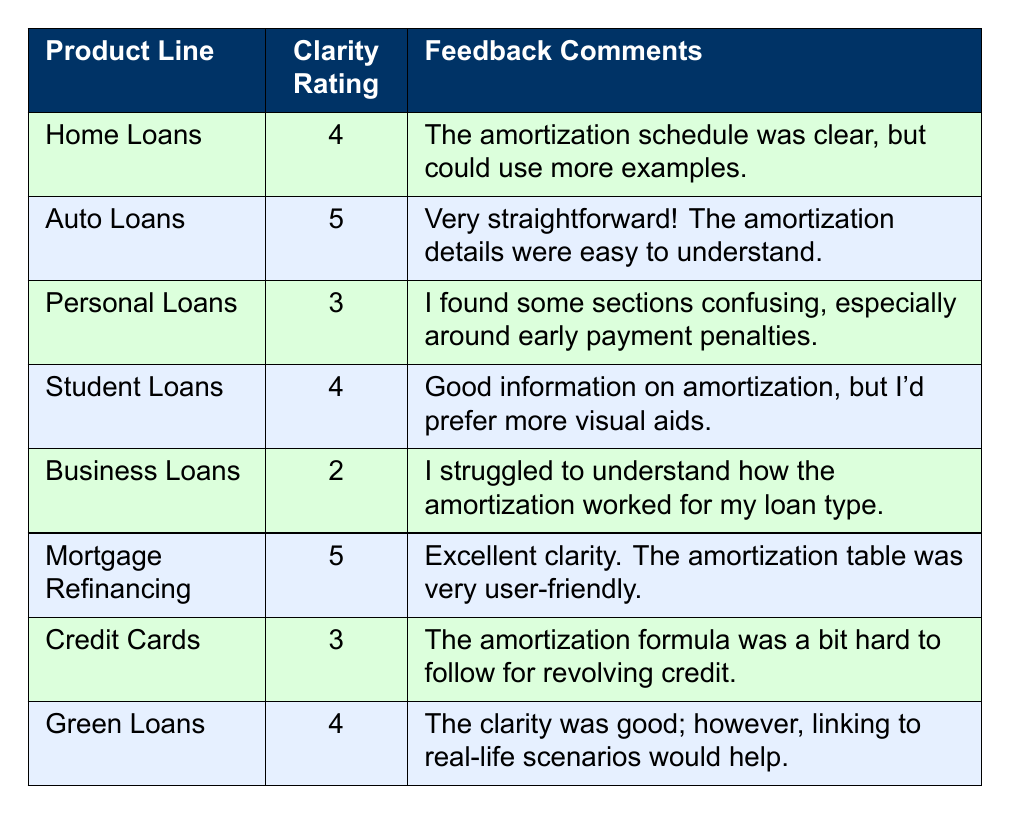What is the clarity rating for Business Loans? The table lists the clarity rating for Business Loans under the "Clarity Rating" column, which shows the value of 2.
Answer: 2 Which product line received the highest clarity rating? By comparing the clarity ratings across all product lines, Auto Loans and Mortgage Refinancing both have the highest rating of 5.
Answer: Auto Loans and Mortgage Refinancing What is the average clarity rating across all product lines? To find the average clarity rating, add all the clarity ratings (4 + 5 + 3 + 4 + 2 + 5 + 3 + 4 = 30) and divide by the number of product lines (8). Thus, the average is 30/8 = 3.75.
Answer: 3.75 Did any product line receive a clarity rating lower than 3? Check the clarity ratings in the table, and it reveals that Business Loans has a rating of 2, confirming that this product line did receive a score lower than 3.
Answer: Yes Which product line's feedback mentioned a need for more visual aids? Reviewing the feedback comments for each product line, the comment for Student Loans specifically states a preference for more visual aids.
Answer: Student Loans If we categorize the ratings 1-2 as low clarity, 3 as medium clarity, and 4-5 as high clarity, how many product lines are considered high clarity? The high clarity ratings are 4 and 5. Counting the product lines with these ratings (Home Loans, Auto Loans, Student Loans, Mortgage Refinancing, and Green Loans), there are a total of 5 product lines that fit this category.
Answer: 5 Is there a product line that received a clarity rating of exactly 3? Looking in the clarity ratings column, both Personal Loans and Credit Cards show a rating of 3, confirming the existence of product lines with this rating.
Answer: Yes Which product line had the feedback comment indicating confusion about early payment penalties? The entry for Personal Loans contains feedback indicating some confusion, especially concerning early payment penalties.
Answer: Personal Loans 